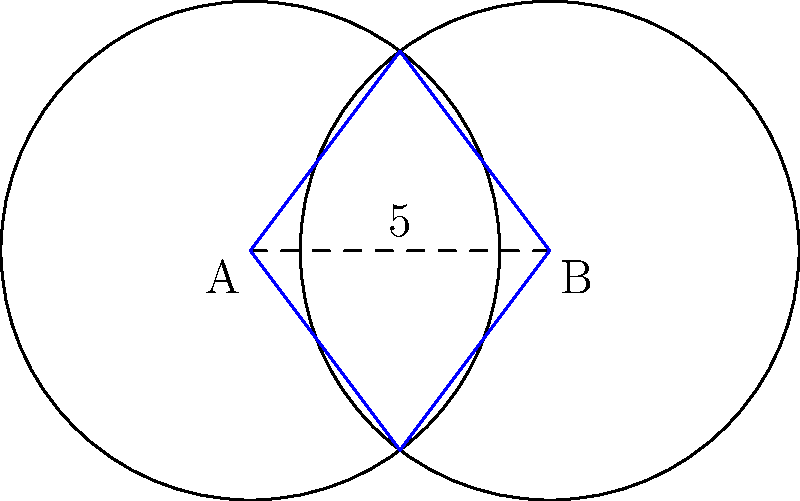At Queen Creek High School, two circular soccer practice zones overlap. Each zone has a radius of 5 yards, and their centers are 6 yards apart. Calculate the area of the overlapping region (shaded in blue) where both teams can practice together. Round your answer to the nearest square yard. Let's approach this step-by-step:

1) First, we need to find the central angle of the sector in one circle. We can do this using the cosine formula:

   $\cos(\theta/2) = \frac{d}{2r} = \frac{6}{2(5)} = 0.6$

   Where $d$ is the distance between centers and $r$ is the radius.

2) Therefore, $\theta = 2 \arccos(0.6) \approx 1.8849$ radians

3) The area of the sector is:

   $A_{sector} = \frac{1}{2}r^2\theta = \frac{1}{2}(5^2)(1.8849) \approx 23.5613$ square yards

4) The area of the triangle formed by the two circle centers and one intersection point is:

   $A_{triangle} = \frac{1}{2}(6)(5\sin(\theta/2)) = 15\sin(\arccos(0.6)) = 12$ square yards

5) The area of the overlap is twice the difference between the sector and the triangle:

   $A_{overlap} = 2(A_{sector} - A_{triangle}) = 2(23.5613 - 12) \approx 23.1226$ square yards

6) Rounding to the nearest square yard gives us 23 square yards.
Answer: 23 square yards 